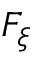<formula> <loc_0><loc_0><loc_500><loc_500>F _ { \xi }</formula> 